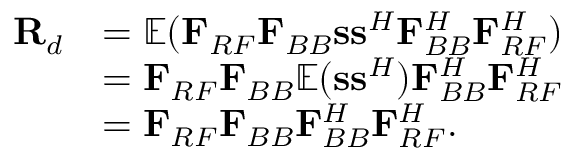Convert formula to latex. <formula><loc_0><loc_0><loc_500><loc_500>\begin{array} { r l } { { R _ { d } } } & { = { \mathbb { E } } ( { { F } _ { R F } } { { F } _ { B B } } { s s ^ { H } } { F } _ { B B } ^ { H } { F } _ { R F } ^ { H } ) } \\ & { = { { F } _ { R F } } { { F } _ { B B } } { \mathbb { E } } ( { s } { { s } ^ { H } } ) { F } _ { B B } ^ { H } { F } _ { R F } ^ { H } } \\ & { = { { F } _ { R F } } { { F } _ { B B } } { F } _ { B B } ^ { H } { F } _ { R F } ^ { H } . } \end{array}</formula> 